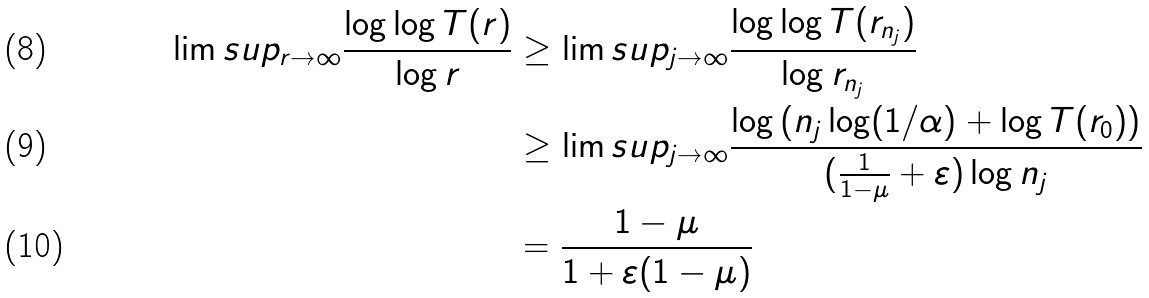<formula> <loc_0><loc_0><loc_500><loc_500>\lim s u p _ { r \to \infty } \frac { \log \log T ( r ) } { \log r } & \geq \lim s u p _ { j \rightarrow \infty } \frac { \log \log T ( r _ { n _ { j } } ) } { \log r _ { n _ { j } } } \\ & \geq \lim s u p _ { j \rightarrow \infty } \frac { \log \left ( n _ { j } \log ( 1 / \alpha ) + \log T ( r _ { 0 } ) \right ) } { ( \frac { 1 } { 1 - \mu } + \varepsilon ) \log n _ { j } } \\ & = \frac { 1 - \mu } { 1 + \varepsilon ( 1 - \mu ) }</formula> 